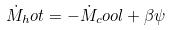<formula> <loc_0><loc_0><loc_500><loc_500>\dot { M } _ { h } o t = - \dot { M } _ { c } o o l + \beta \psi</formula> 